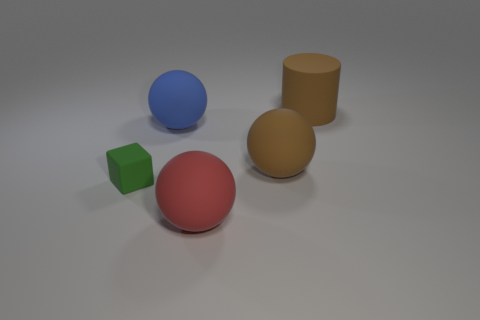What is the material of the big brown object that is the same shape as the large blue matte thing?
Make the answer very short. Rubber. What size is the ball that is the same color as the large matte cylinder?
Give a very brief answer. Large. How many big things are on the right side of the large sphere left of the large red thing?
Your response must be concise. 3. How many other things are there of the same material as the green object?
Give a very brief answer. 4. Do the object that is in front of the green matte block and the big brown thing that is in front of the blue sphere have the same material?
Keep it short and to the point. Yes. Are there any other things that are the same shape as the big blue matte object?
Provide a succinct answer. Yes. Are the brown ball and the big sphere behind the big brown ball made of the same material?
Keep it short and to the point. Yes. There is a small cube that is in front of the large thing on the right side of the big brown rubber thing that is in front of the big cylinder; what color is it?
Offer a very short reply. Green. There is a red rubber thing that is the same size as the blue matte sphere; what is its shape?
Keep it short and to the point. Sphere. Are there any other things that are the same size as the blue rubber sphere?
Provide a succinct answer. Yes. 